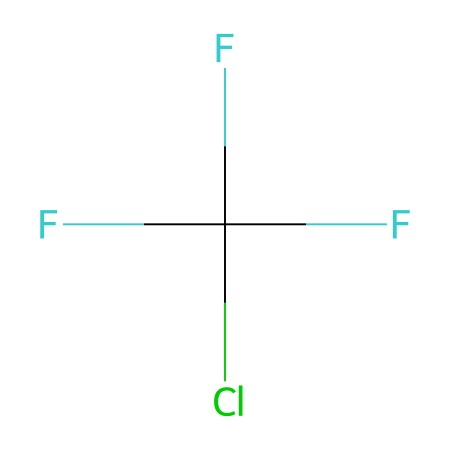what is the name of this chemical? The SMILES represents a compound that consists of chlorine and fluorine atoms arranged in a specific structure. Based on the functional groups present, it corresponds to a common refrigerant known as trifluorochloromethane or CFC-11.
Answer: trifluorochloromethane how many carbon atoms are in this chemical? The SMILES indicates that there is one carbon atom present in the structure, as denoted by the presence of "C" in the notation.
Answer: one how many fluorine atoms are in this chemical? The SMILES shows that there are three fluorine atoms bonded to the carbon atom, as shown by the three "F" symbols in the representation.
Answer: three is this chemical a gas at room temperature? Trifluorochloromethane is known to be a gas at room temperature, based on its properties relating to molecular weight and structure, which is typically a characteristic of CFCs.
Answer: yes what functional group is present in this chemical? The structure contains a chlorine atom and multiple fluorine atoms bonded to carbon. The presence of fluorine and chlorine makes it a halogenated compound, indicating that the functional group is halogen (CFC).
Answer: halogen does this compound contribute to ozone depletion? CFC-11 is classified as an ozone-depleting substance, and its molecular structure, which includes chlorine, is responsible for its ability to impact the ozone layer through photodissociation reactions in the stratosphere.
Answer: yes can this chemical be used as a refrigerant? Yes, trifluorochloromethane is commonly used as a refrigerant due to its physical properties that allow it to effectively absorb heat while maintaining stability at operational temperatures.
Answer: yes 